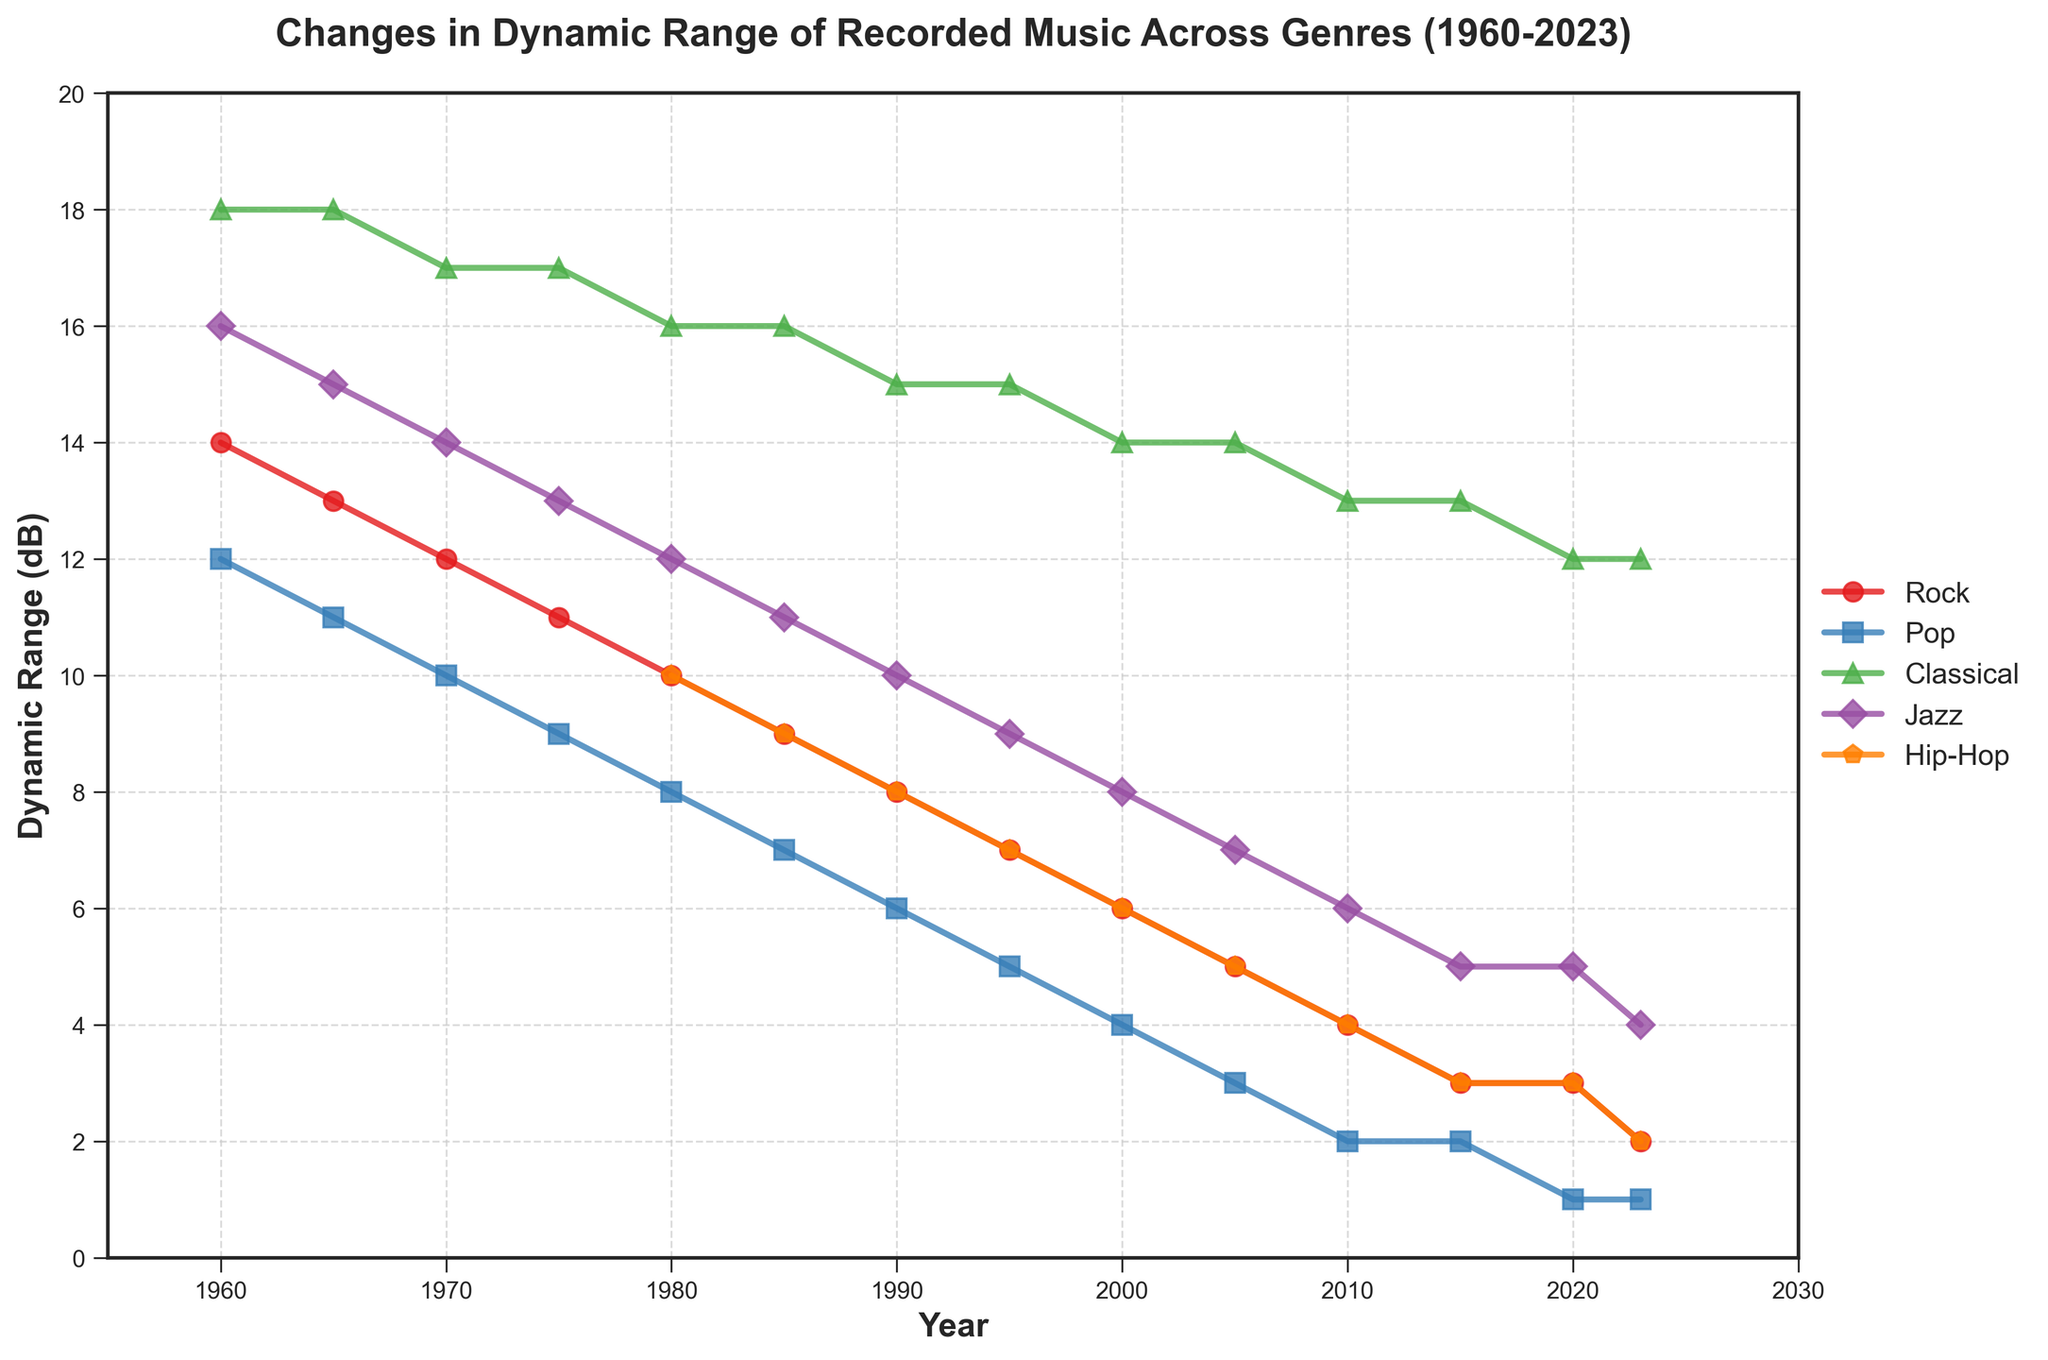Which genre shows the highest dynamic range in 2023? According to the figure, in 2023, the genres display their values on the y-axis. Classical has the highest value at 12 dB among all genres.
Answer: Classical How did the dynamic range of Rock music change from 1960 to 2023? From 1960 to 2023, the dynamic range of Rock music decreased from 14 dB to 2 dB, which indicates a substantial reduction.
Answer: Decreased from 14 dB to 2 dB Which genre had the smallest change in dynamic range from 1960 to 2023? By observing the differences between initial and final dynamic range values, Classical showed the least change, dropping only from 18 dB to 12 dB, a 6 dB reduction compared to larger reductions in other genres.
Answer: Classical In which year did the dynamic ranges of Rock and Pop first equal each other? Both Rock and Pop first have the same dynamic range value at 3 dB in the year 2015.
Answer: 2015 What's the average dynamic range of Jazz music for the years 1980, 1990, and 2000? For Jazz, the dynamic range values in 1980, 1990, and 2000 are 12 dB, 10 dB, and 8 dB respectively. The average is calculated as (12 + 10 + 8) / 3 = 10 dB.
Answer: 10 dB Which genre shows the steepest decline in dynamic range between 1960 and 2023? By comparing the starting and ending values, Pop shows the steepest decline, going from 12 dB to 1 dB, which is an 11 dB reduction over the period.
Answer: Pop Between which years did Hip-Hop music undergo the greatest decline in dynamic range? Observing the Hip-Hop plot, the greatest decline occurs between 1980 and 1985, dropping from 10 dB to 9 dB, a 1 dB decrease.
Answer: 1980 to 1985 Which genre has the second lowest dynamic range in 2023? In 2023, Pop and Hip-Hop both have a dynamic range of 1 dB, which is the lowest. The second lowest is Rock with 2 dB.
Answer: Rock By how many dB did the dynamic range of Classical music decrease from 1960 to 2023? The dynamic range of Classical music decreased from 18 dB in 1960 to 12 dB in 2023, indicating a decline of 6 dB.
Answer: 6 dB Compare the dynamic range trends of Rock and Hip-Hop from 1960 to 2023. Both Rock and Hip-Hop show a decreasing trend from 1960 to 2023. Rock decreased from 14 dB to 2 dB, while Hip-Hop, which appears starting from 1980, decreased from 10 dB to 2 dB.
Answer: Both decreased 